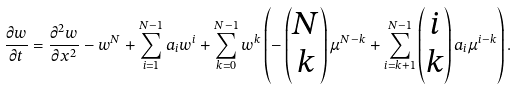<formula> <loc_0><loc_0><loc_500><loc_500>\frac { \partial w } { \partial t } = \frac { \partial ^ { 2 } w } { \partial x ^ { 2 } } - w ^ { N } + \sum _ { i = 1 } ^ { N - 1 } a _ { i } w ^ { i } + \sum _ { k = 0 } ^ { N - 1 } w ^ { k } \left ( - \begin{pmatrix} N \\ k \end{pmatrix} \mu ^ { N - k } + \sum _ { i = k + 1 } ^ { N - 1 } \begin{pmatrix} i \\ k \end{pmatrix} a _ { i } \mu ^ { i - k } \right ) .</formula> 